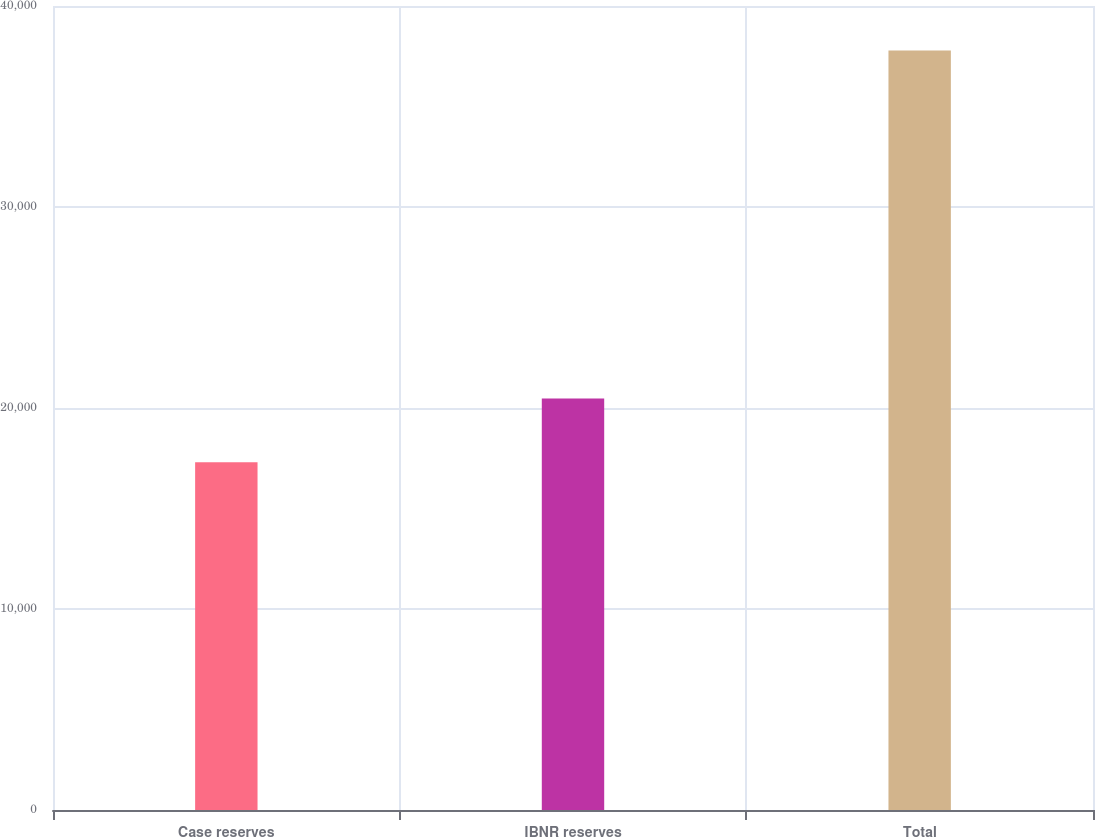<chart> <loc_0><loc_0><loc_500><loc_500><bar_chart><fcel>Case reserves<fcel>IBNR reserves<fcel>Total<nl><fcel>17307<fcel>20476<fcel>37783<nl></chart> 